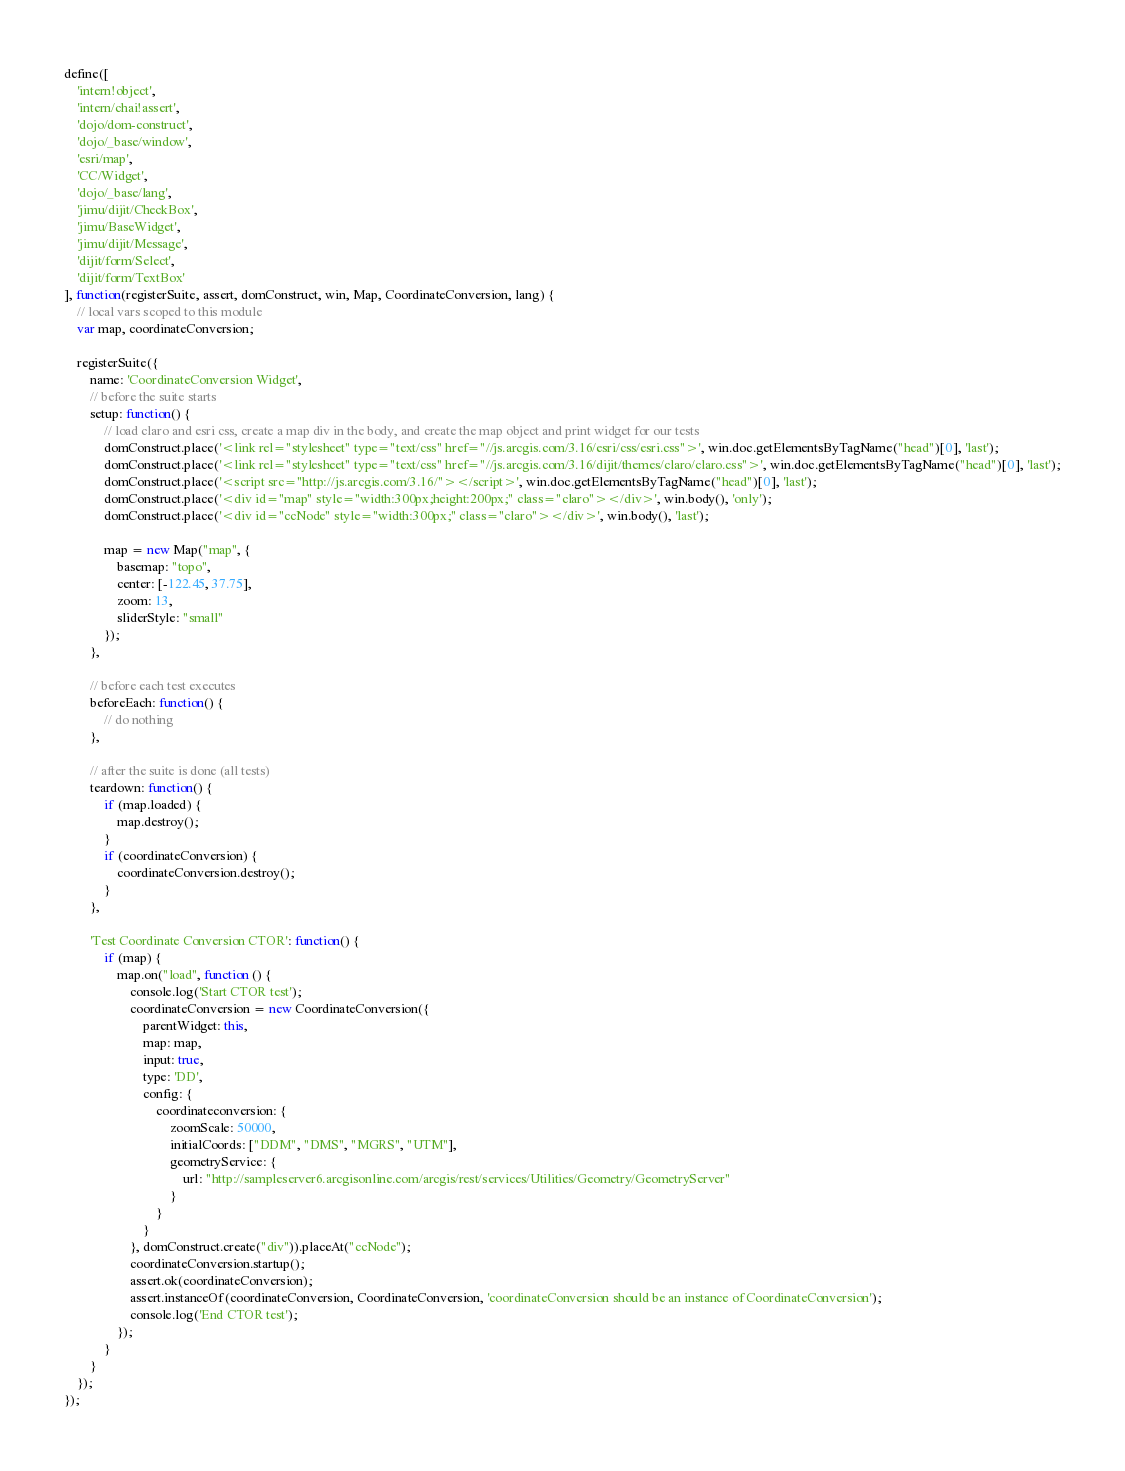<code> <loc_0><loc_0><loc_500><loc_500><_JavaScript_>define([
    'intern!object',
    'intern/chai!assert',
    'dojo/dom-construct',
    'dojo/_base/window',
    'esri/map',
    'CC/Widget',
    'dojo/_base/lang',
    'jimu/dijit/CheckBox',
    'jimu/BaseWidget',
    'jimu/dijit/Message',
    'dijit/form/Select',
    'dijit/form/TextBox'
], function(registerSuite, assert, domConstruct, win, Map, CoordinateConversion, lang) {
    // local vars scoped to this module
    var map, coordinateConversion;

    registerSuite({
        name: 'CoordinateConversion Widget',
        // before the suite starts
        setup: function() {
            // load claro and esri css, create a map div in the body, and create the map object and print widget for our tests
            domConstruct.place('<link rel="stylesheet" type="text/css" href="//js.arcgis.com/3.16/esri/css/esri.css">', win.doc.getElementsByTagName("head")[0], 'last');
            domConstruct.place('<link rel="stylesheet" type="text/css" href="//js.arcgis.com/3.16/dijit/themes/claro/claro.css">', win.doc.getElementsByTagName("head")[0], 'last');
            domConstruct.place('<script src="http://js.arcgis.com/3.16/"></script>', win.doc.getElementsByTagName("head")[0], 'last');
            domConstruct.place('<div id="map" style="width:300px;height:200px;" class="claro"></div>', win.body(), 'only');
            domConstruct.place('<div id="ccNode" style="width:300px;" class="claro"></div>', win.body(), 'last');

            map = new Map("map", {
                basemap: "topo",
                center: [-122.45, 37.75],
                zoom: 13,
                sliderStyle: "small"
            });
        },

        // before each test executes
        beforeEach: function() {
            // do nothing
        },

        // after the suite is done (all tests)
        teardown: function() {
            if (map.loaded) {
                map.destroy();    
            }
            if (coordinateConversion) {
                coordinateConversion.destroy();
            }            
        },

        'Test Coordinate Conversion CTOR': function() {
            if (map) {
                map.on("load", function () {
                    console.log('Start CTOR test');
                    coordinateConversion = new CoordinateConversion({
                        parentWidget: this,
                        map: map,
                        input: true,
                        type: 'DD',
                        config: {
                            coordinateconversion: {
                                zoomScale: 50000,
                                initialCoords: ["DDM", "DMS", "MGRS", "UTM"],
                                geometryService: {
                                    url: "http://sampleserver6.arcgisonline.com/arcgis/rest/services/Utilities/Geometry/GeometryServer"
                                }
                            }   
                        }                
                    }, domConstruct.create("div")).placeAt("ccNode");    
                    coordinateConversion.startup();
                    assert.ok(coordinateConversion);
                    assert.instanceOf(coordinateConversion, CoordinateConversion, 'coordinateConversion should be an instance of CoordinateConversion');            
                    console.log('End CTOR test');
                });
            }
        }
    });
});</code> 